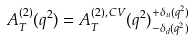Convert formula to latex. <formula><loc_0><loc_0><loc_500><loc_500>A _ { T } ^ { ( 2 ) } ( q ^ { 2 } ) = A _ { T } ^ { ( 2 ) , \, C V } ( q ^ { 2 } ) ^ { + \delta _ { u } ( q ^ { 2 } ) } _ { - \delta _ { d } ( q ^ { 2 } ) }</formula> 